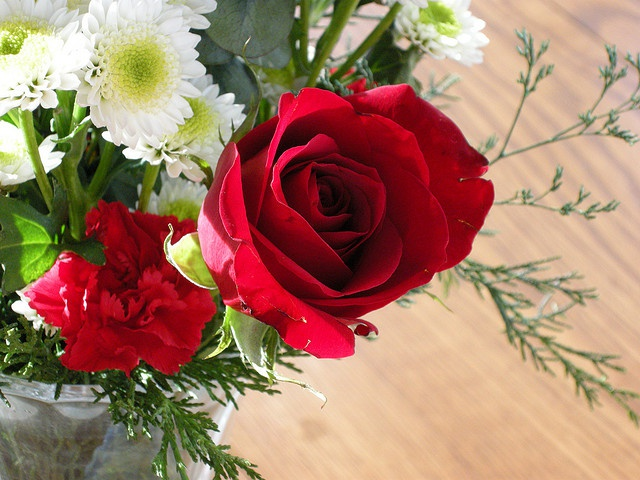Describe the objects in this image and their specific colors. I can see potted plant in lightgray, brown, maroon, and black tones and vase in lightgray, gray, darkgray, and darkgreen tones in this image. 